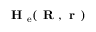Convert formula to latex. <formula><loc_0><loc_0><loc_500><loc_500>H _ { e } ( R , r )</formula> 